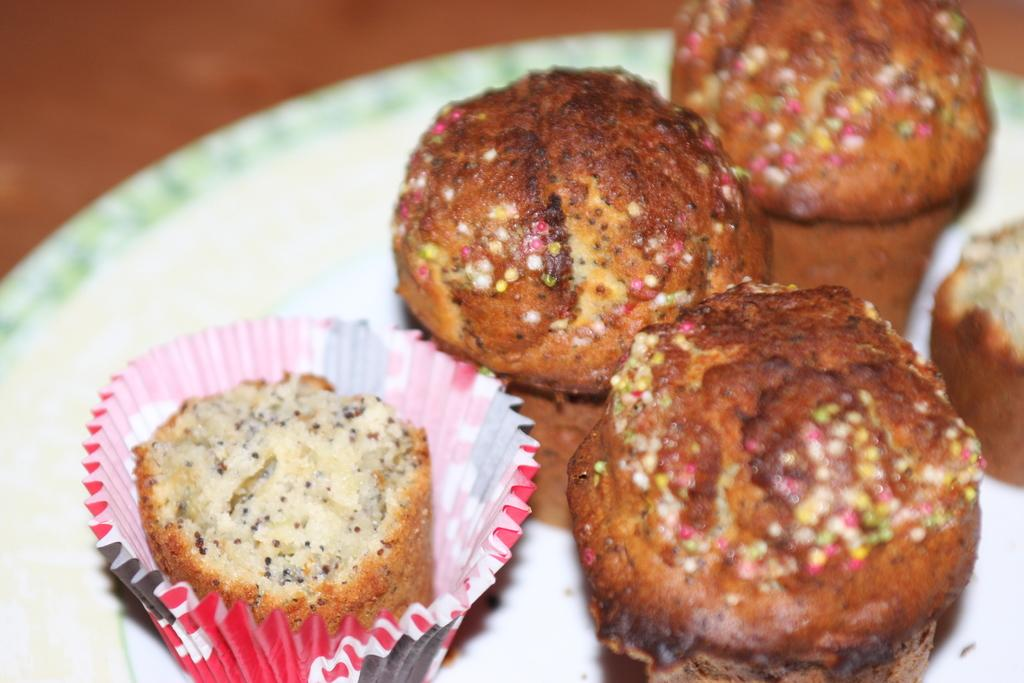What is on the plate in the image? There are food items on the plate in the image. What type of surface can be seen in the background of the image? There is a wooden surface in the background of the image. What type of mark can be seen on the bread in the image? There is no bread present in the image, and therefore no mark can be observed on it. 